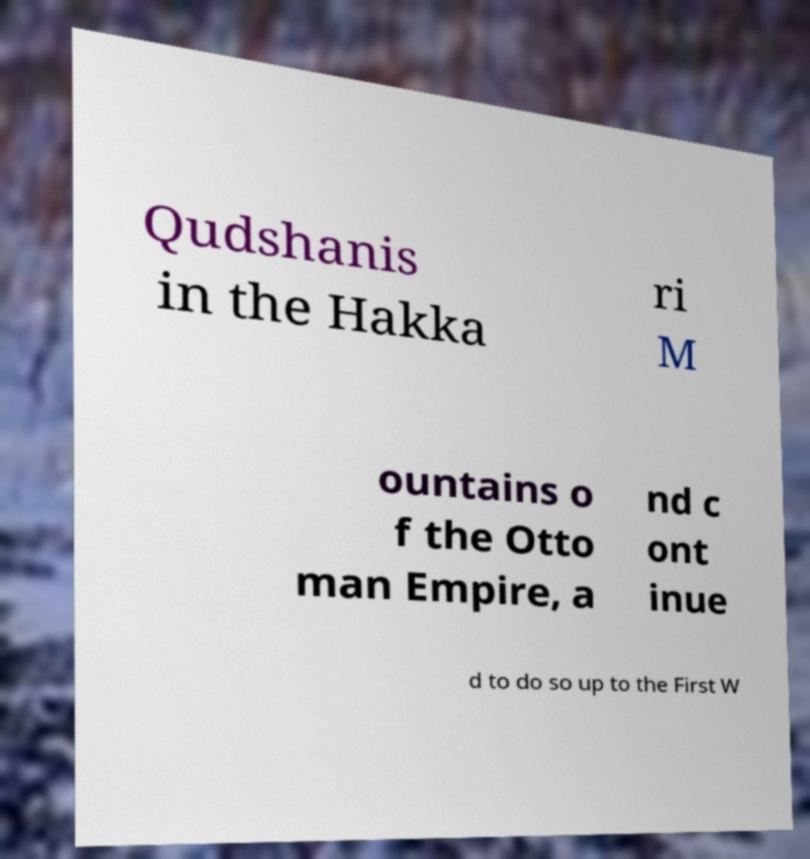What messages or text are displayed in this image? I need them in a readable, typed format. Qudshanis in the Hakka ri M ountains o f the Otto man Empire, a nd c ont inue d to do so up to the First W 